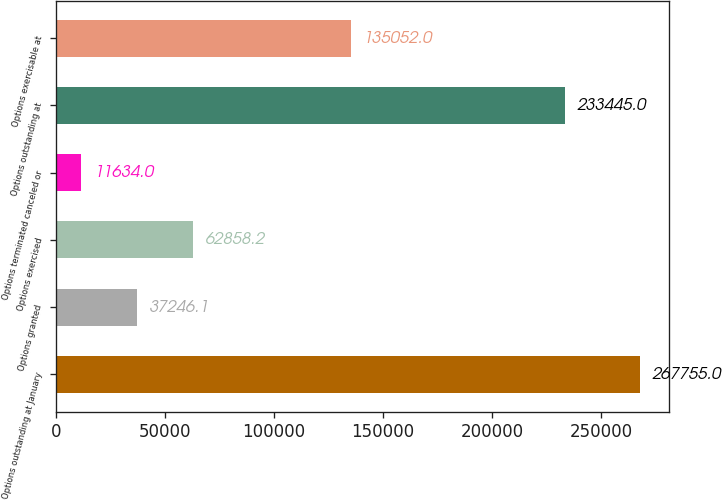Convert chart. <chart><loc_0><loc_0><loc_500><loc_500><bar_chart><fcel>Options outstanding at January<fcel>Options granted<fcel>Options exercised<fcel>Options terminated canceled or<fcel>Options outstanding at<fcel>Options exercisable at<nl><fcel>267755<fcel>37246.1<fcel>62858.2<fcel>11634<fcel>233445<fcel>135052<nl></chart> 